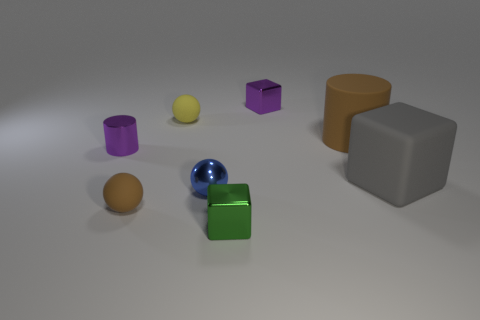How many other objects are the same material as the purple cube?
Your response must be concise. 3. Is the material of the purple cylinder the same as the cylinder right of the brown ball?
Provide a short and direct response. No. What number of things are tiny rubber spheres that are behind the gray rubber cube or blocks behind the blue thing?
Keep it short and to the point. 3. What number of other things are the same color as the small shiny cylinder?
Your answer should be very brief. 1. Is the number of metallic cubes on the left side of the purple shiny block greater than the number of rubber cylinders in front of the blue ball?
Offer a terse response. Yes. How many cylinders are either big things or small blue shiny objects?
Your answer should be compact. 1. How many things are metallic blocks in front of the small blue object or purple shiny objects?
Keep it short and to the point. 3. What is the shape of the big rubber object that is behind the tiny purple thing that is left of the small block behind the gray block?
Provide a succinct answer. Cylinder. How many other metallic things are the same shape as the green metallic object?
Ensure brevity in your answer.  1. There is a ball that is the same color as the large rubber cylinder; what is its material?
Give a very brief answer. Rubber. 